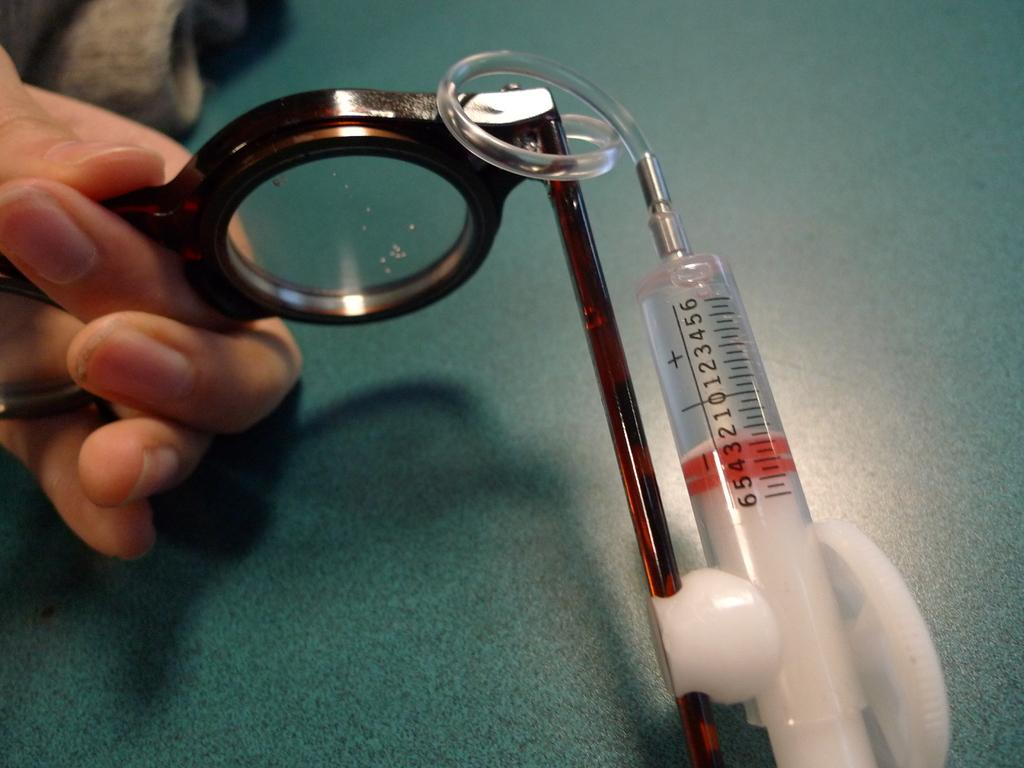<image>
Create a compact narrative representing the image presented. A person is holding a syringe that is numbered from 0 to 6. 